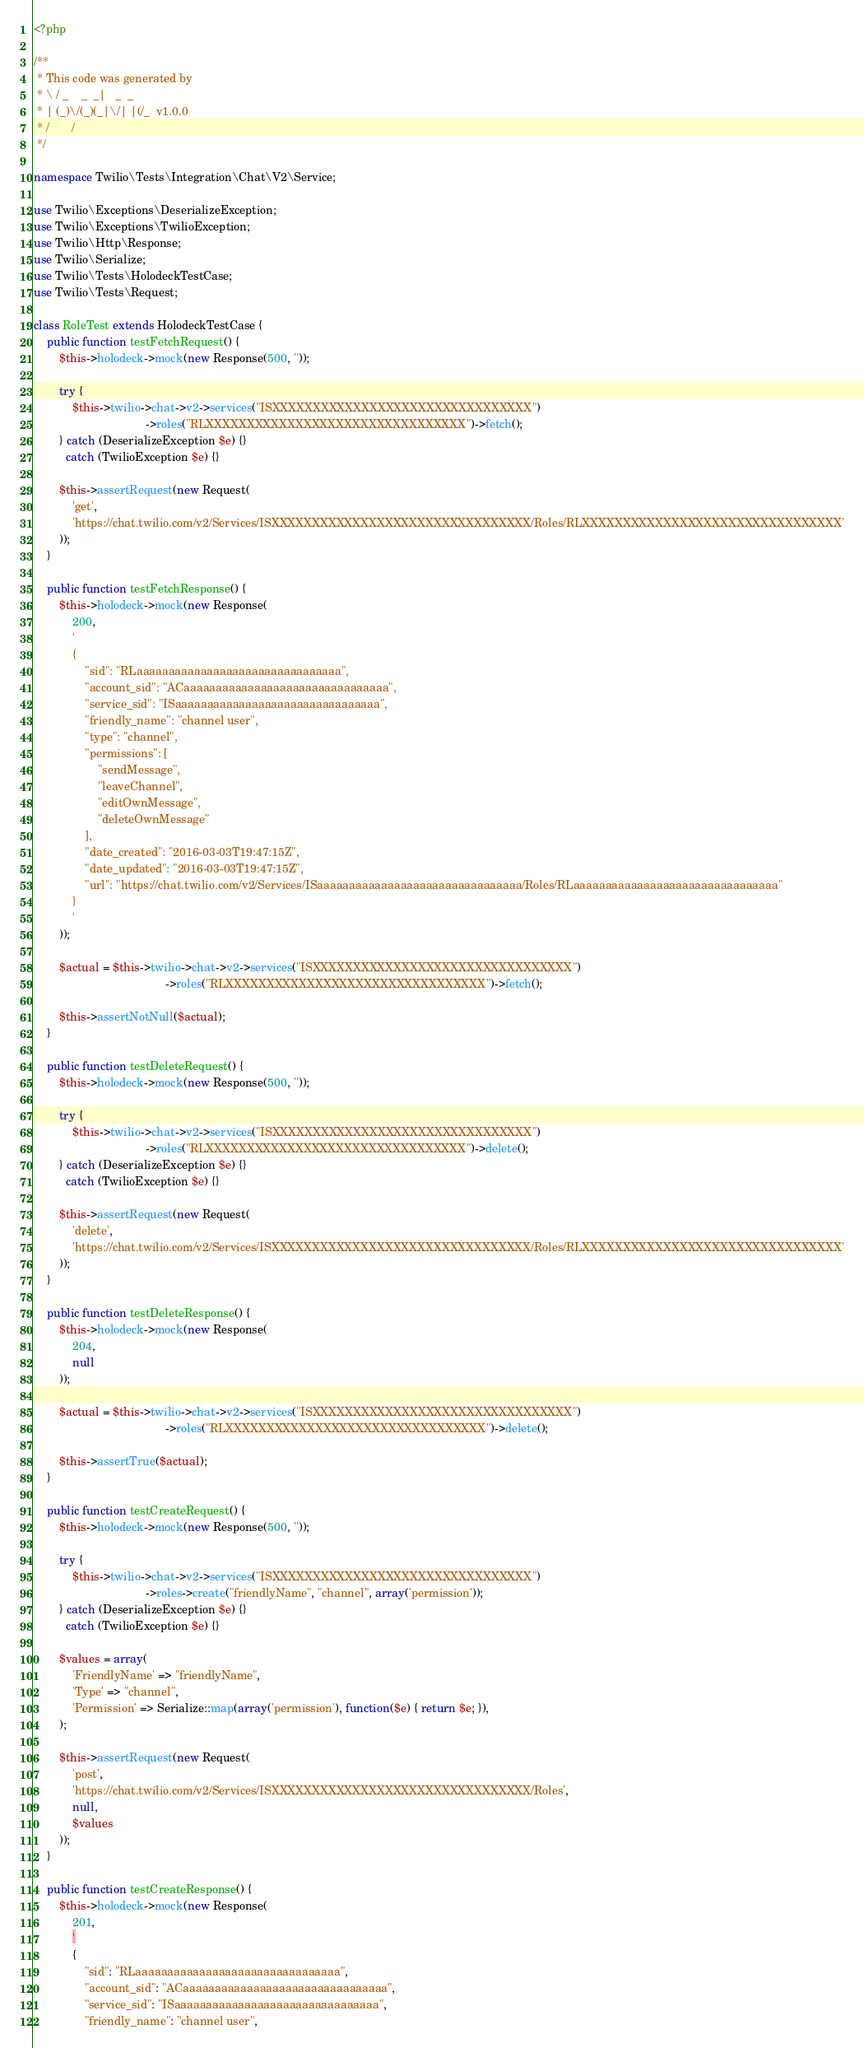Convert code to text. <code><loc_0><loc_0><loc_500><loc_500><_PHP_><?php

/**
 * This code was generated by
 * \ / _    _  _|   _  _
 * | (_)\/(_)(_|\/| |(/_  v1.0.0
 * /       /
 */

namespace Twilio\Tests\Integration\Chat\V2\Service;

use Twilio\Exceptions\DeserializeException;
use Twilio\Exceptions\TwilioException;
use Twilio\Http\Response;
use Twilio\Serialize;
use Twilio\Tests\HolodeckTestCase;
use Twilio\Tests\Request;

class RoleTest extends HolodeckTestCase {
    public function testFetchRequest() {
        $this->holodeck->mock(new Response(500, ''));

        try {
            $this->twilio->chat->v2->services("ISXXXXXXXXXXXXXXXXXXXXXXXXXXXXXXXX")
                                   ->roles("RLXXXXXXXXXXXXXXXXXXXXXXXXXXXXXXXX")->fetch();
        } catch (DeserializeException $e) {}
          catch (TwilioException $e) {}

        $this->assertRequest(new Request(
            'get',
            'https://chat.twilio.com/v2/Services/ISXXXXXXXXXXXXXXXXXXXXXXXXXXXXXXXX/Roles/RLXXXXXXXXXXXXXXXXXXXXXXXXXXXXXXXX'
        ));
    }

    public function testFetchResponse() {
        $this->holodeck->mock(new Response(
            200,
            '
            {
                "sid": "RLaaaaaaaaaaaaaaaaaaaaaaaaaaaaaaaa",
                "account_sid": "ACaaaaaaaaaaaaaaaaaaaaaaaaaaaaaaaa",
                "service_sid": "ISaaaaaaaaaaaaaaaaaaaaaaaaaaaaaaaa",
                "friendly_name": "channel user",
                "type": "channel",
                "permissions": [
                    "sendMessage",
                    "leaveChannel",
                    "editOwnMessage",
                    "deleteOwnMessage"
                ],
                "date_created": "2016-03-03T19:47:15Z",
                "date_updated": "2016-03-03T19:47:15Z",
                "url": "https://chat.twilio.com/v2/Services/ISaaaaaaaaaaaaaaaaaaaaaaaaaaaaaaaa/Roles/RLaaaaaaaaaaaaaaaaaaaaaaaaaaaaaaaa"
            }
            '
        ));

        $actual = $this->twilio->chat->v2->services("ISXXXXXXXXXXXXXXXXXXXXXXXXXXXXXXXX")
                                         ->roles("RLXXXXXXXXXXXXXXXXXXXXXXXXXXXXXXXX")->fetch();

        $this->assertNotNull($actual);
    }

    public function testDeleteRequest() {
        $this->holodeck->mock(new Response(500, ''));

        try {
            $this->twilio->chat->v2->services("ISXXXXXXXXXXXXXXXXXXXXXXXXXXXXXXXX")
                                   ->roles("RLXXXXXXXXXXXXXXXXXXXXXXXXXXXXXXXX")->delete();
        } catch (DeserializeException $e) {}
          catch (TwilioException $e) {}

        $this->assertRequest(new Request(
            'delete',
            'https://chat.twilio.com/v2/Services/ISXXXXXXXXXXXXXXXXXXXXXXXXXXXXXXXX/Roles/RLXXXXXXXXXXXXXXXXXXXXXXXXXXXXXXXX'
        ));
    }

    public function testDeleteResponse() {
        $this->holodeck->mock(new Response(
            204,
            null
        ));

        $actual = $this->twilio->chat->v2->services("ISXXXXXXXXXXXXXXXXXXXXXXXXXXXXXXXX")
                                         ->roles("RLXXXXXXXXXXXXXXXXXXXXXXXXXXXXXXXX")->delete();

        $this->assertTrue($actual);
    }

    public function testCreateRequest() {
        $this->holodeck->mock(new Response(500, ''));

        try {
            $this->twilio->chat->v2->services("ISXXXXXXXXXXXXXXXXXXXXXXXXXXXXXXXX")
                                   ->roles->create("friendlyName", "channel", array('permission'));
        } catch (DeserializeException $e) {}
          catch (TwilioException $e) {}

        $values = array(
            'FriendlyName' => "friendlyName",
            'Type' => "channel",
            'Permission' => Serialize::map(array('permission'), function($e) { return $e; }),
        );

        $this->assertRequest(new Request(
            'post',
            'https://chat.twilio.com/v2/Services/ISXXXXXXXXXXXXXXXXXXXXXXXXXXXXXXXX/Roles',
            null,
            $values
        ));
    }

    public function testCreateResponse() {
        $this->holodeck->mock(new Response(
            201,
            '
            {
                "sid": "RLaaaaaaaaaaaaaaaaaaaaaaaaaaaaaaaa",
                "account_sid": "ACaaaaaaaaaaaaaaaaaaaaaaaaaaaaaaaa",
                "service_sid": "ISaaaaaaaaaaaaaaaaaaaaaaaaaaaaaaaa",
                "friendly_name": "channel user",</code> 